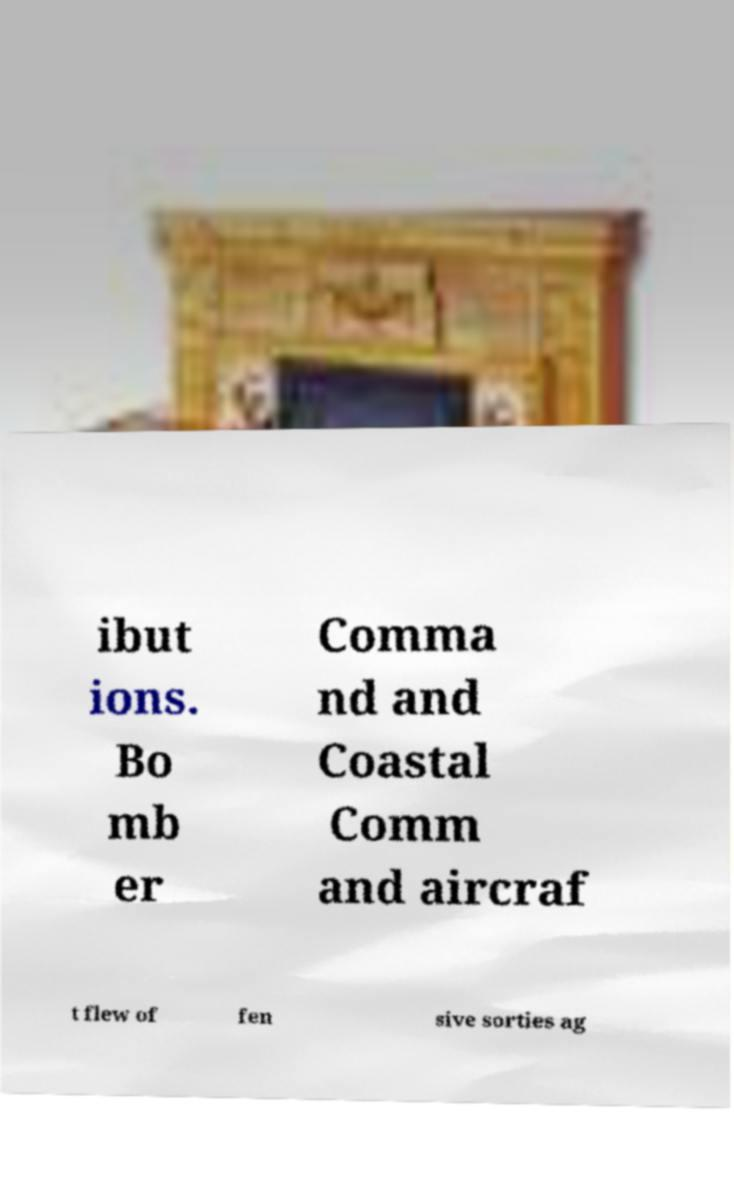Please identify and transcribe the text found in this image. ibut ions. Bo mb er Comma nd and Coastal Comm and aircraf t flew of fen sive sorties ag 